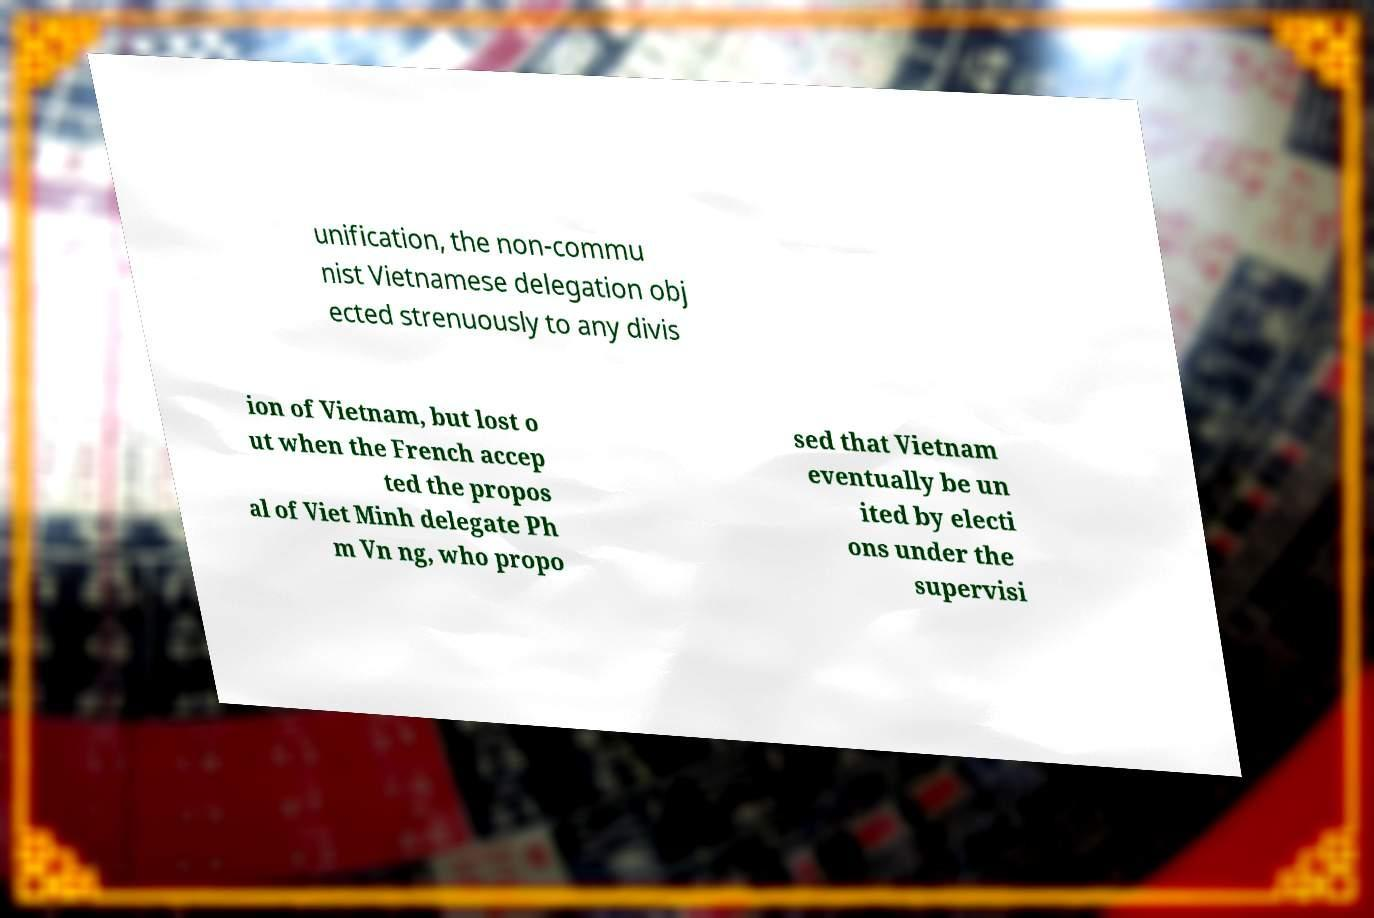Can you accurately transcribe the text from the provided image for me? unification, the non-commu nist Vietnamese delegation obj ected strenuously to any divis ion of Vietnam, but lost o ut when the French accep ted the propos al of Viet Minh delegate Ph m Vn ng, who propo sed that Vietnam eventually be un ited by electi ons under the supervisi 